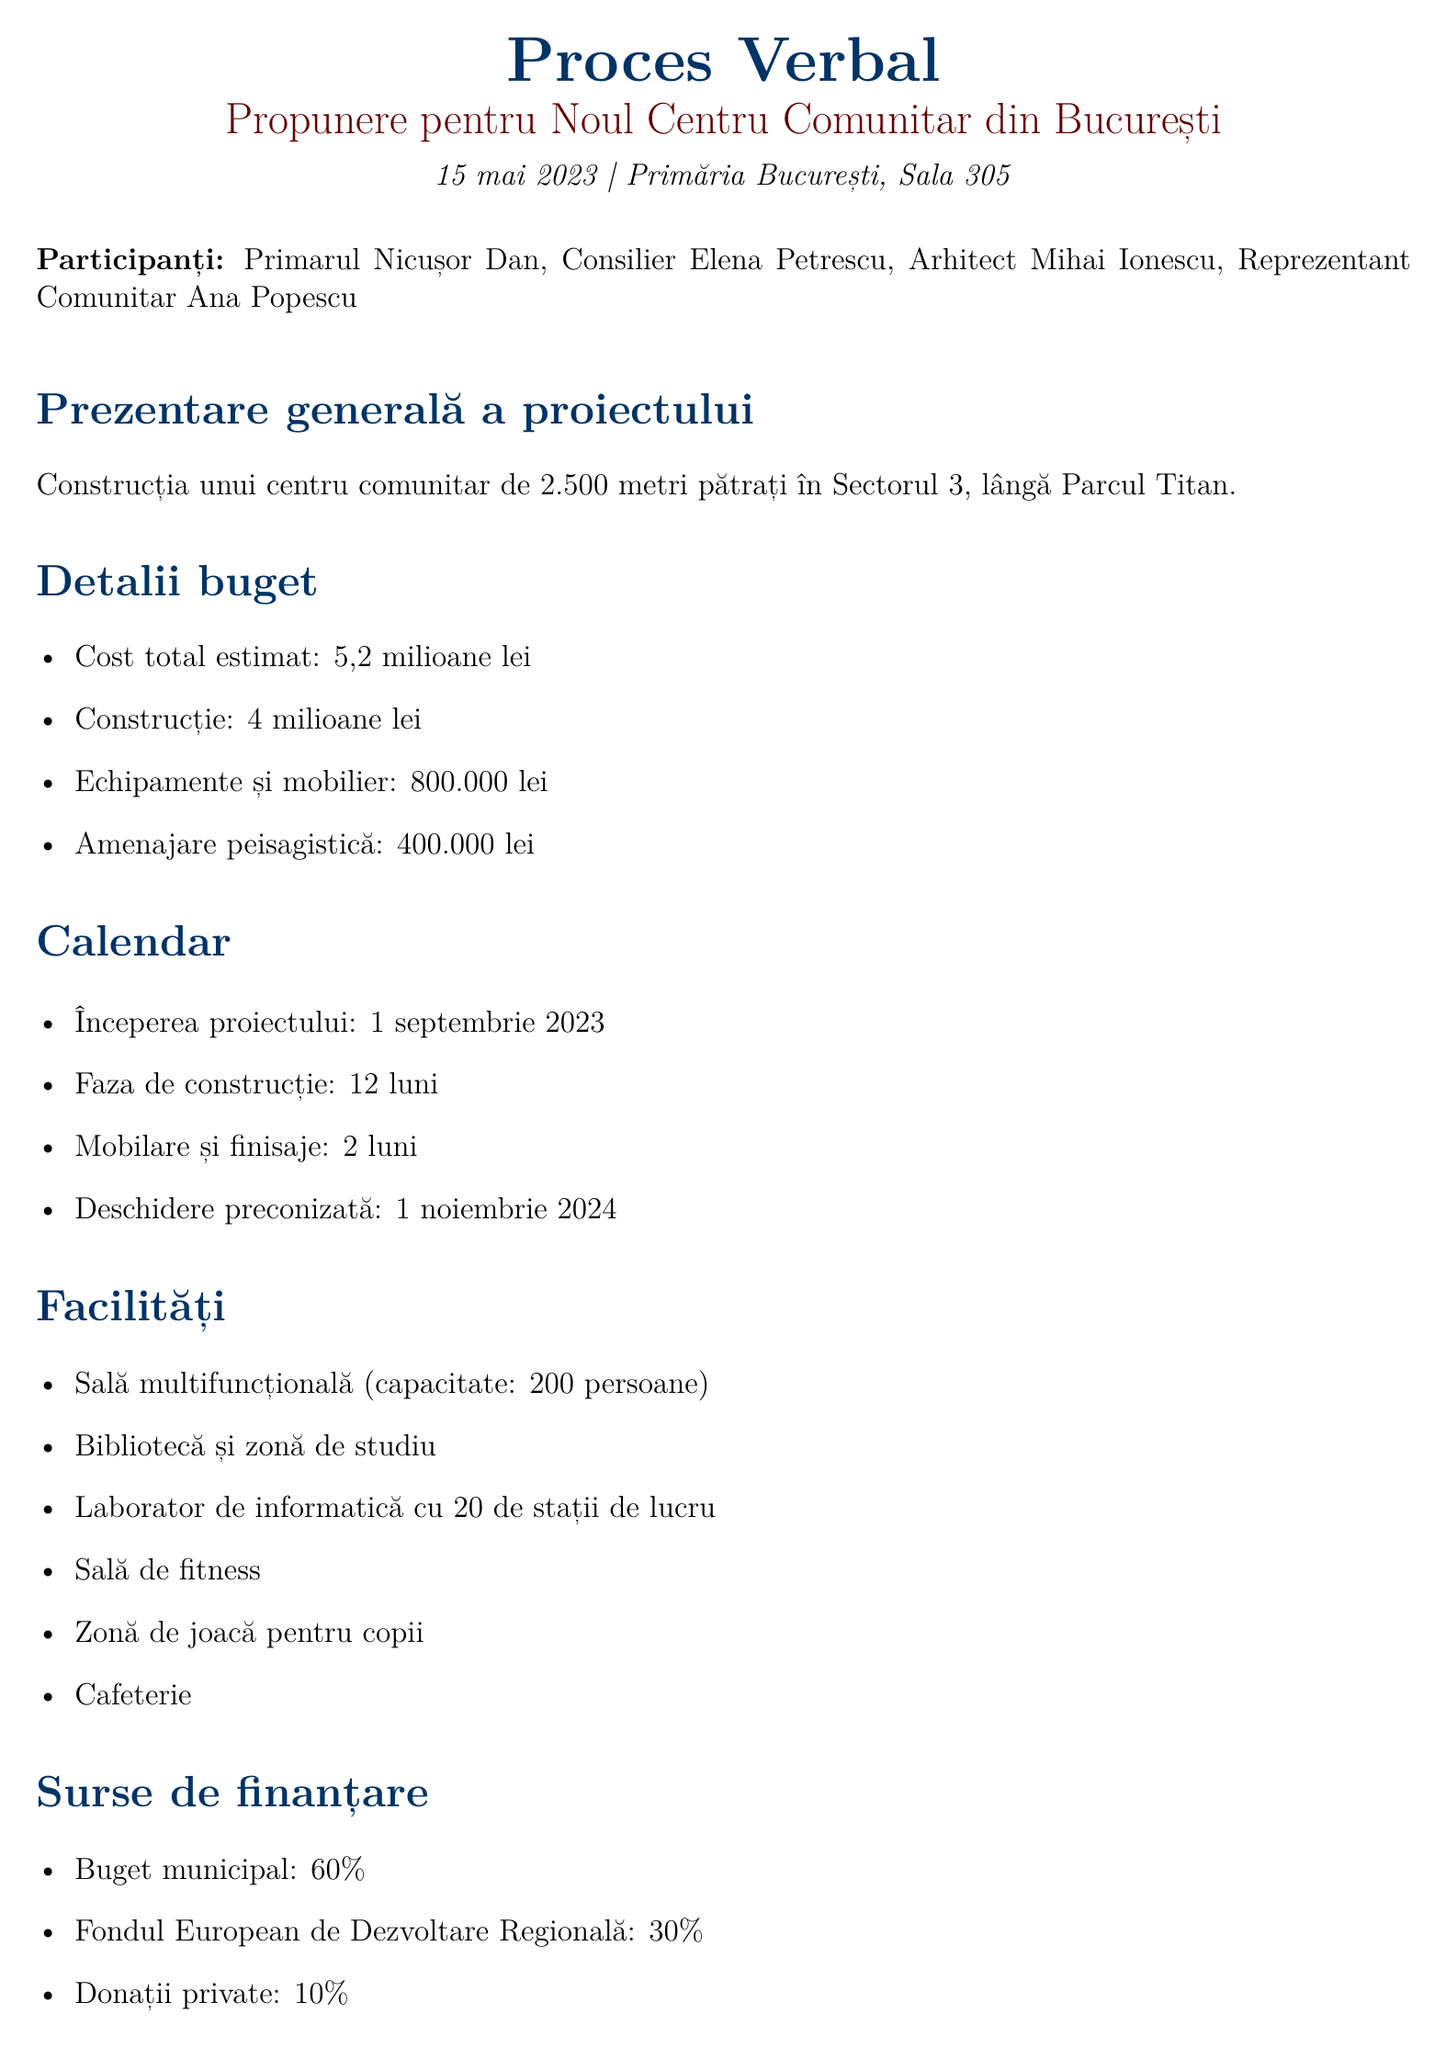What is the estimated total cost of the project? The total estimated cost is listed in the budget breakdown section of the document.
Answer: 5.2 million lei When is the project expected to start? The start date of the project is mentioned in the timeline section.
Answer: September 1, 2023 How long is the construction phase planned to last? The duration of the construction phase is specified in the timeline details.
Answer: 12 months What percentage of funding comes from private donations? The funding sources section outlines the contributions from different sources, including private donations.
Answer: 10% What is the capacity of the multipurpose hall? This information is provided in the facility features section of the document.
Answer: 200 people What are the next steps outlined in the meeting? The next steps are detailed in their own section, summarizing future actions to be taken.
Answer: Finalize architectural plans by June 30, 2023 Who is the community representative attending the meeting? The attendees section lists all participants, including the community representative.
Answer: Ana Popescu What are two benefits for the community mentioned in the document? The community benefits section lists various advantages; two benefits can be selected from this list.
Answer: Improved access to educational resources and job creation for local residents 